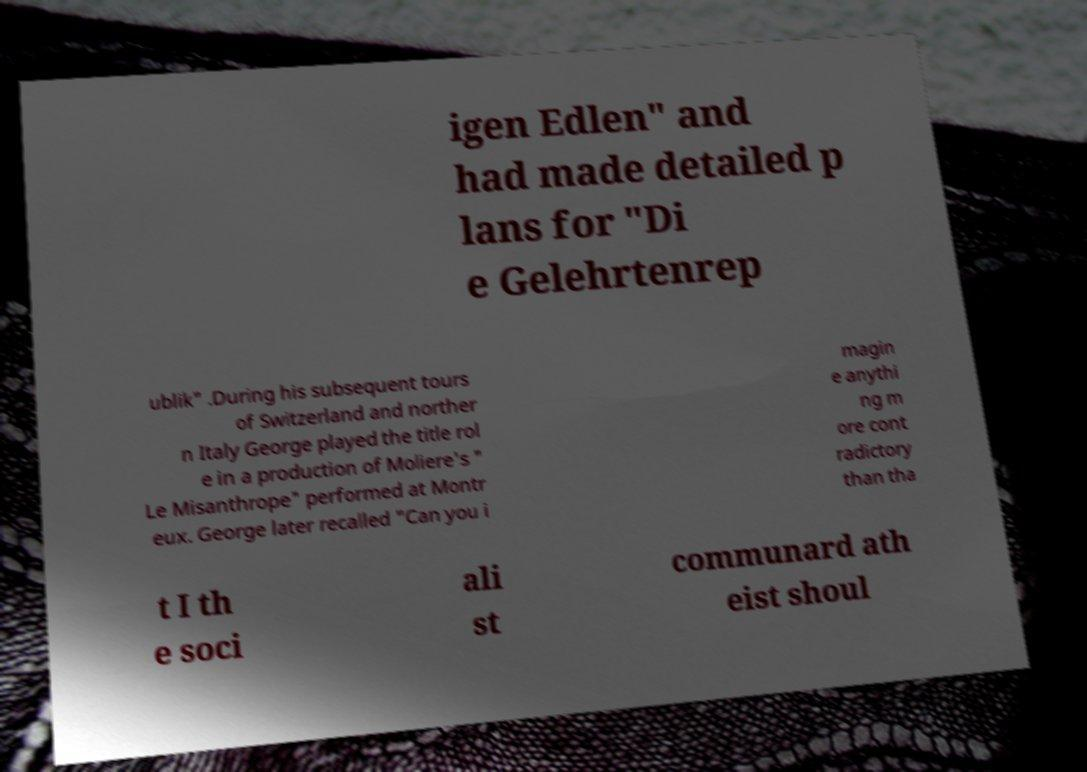Can you read and provide the text displayed in the image?This photo seems to have some interesting text. Can you extract and type it out for me? igen Edlen" and had made detailed p lans for "Di e Gelehrtenrep ublik" .During his subsequent tours of Switzerland and norther n Italy George played the title rol e in a production of Moliere's " Le Misanthrope" performed at Montr eux. George later recalled "Can you i magin e anythi ng m ore cont radictory than tha t I th e soci ali st communard ath eist shoul 